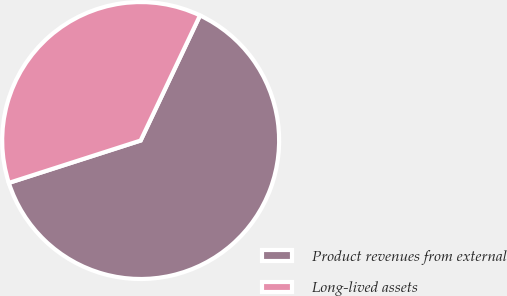<chart> <loc_0><loc_0><loc_500><loc_500><pie_chart><fcel>Product revenues from external<fcel>Long-lived assets<nl><fcel>63.0%<fcel>37.0%<nl></chart> 